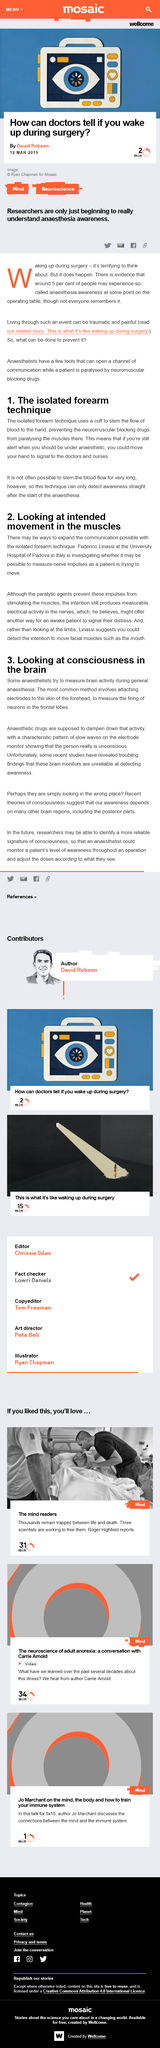Outline some significant characteristics in this image. Anesthetic drugs are used to dampen the firing of neurons in the frontal lobes. This article was published on 12th March 2019, as declared in the text. The isolated forearm technique is capable of detecting awareness only after the start of anesthesia. According to Linassi, instead of focusing on the limbs, it is possible to detect an individual's intention to move facial muscles such as in the mouth. The intention still produces measurable electrical activity in the nerves. 